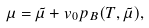<formula> <loc_0><loc_0><loc_500><loc_500>\mu = \tilde { \mu } + v _ { 0 } p _ { B } ( T , \tilde { \mu } ) ,</formula> 